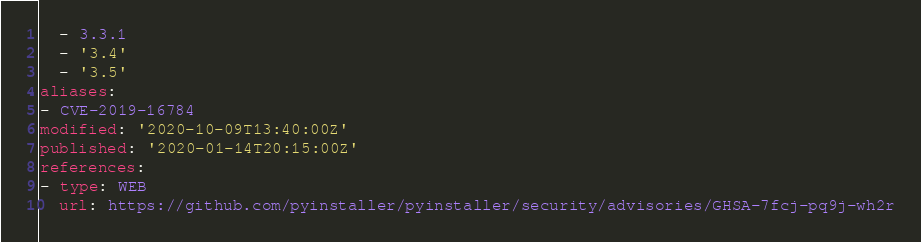Convert code to text. <code><loc_0><loc_0><loc_500><loc_500><_YAML_>  - 3.3.1
  - '3.4'
  - '3.5'
aliases:
- CVE-2019-16784
modified: '2020-10-09T13:40:00Z'
published: '2020-01-14T20:15:00Z'
references:
- type: WEB
  url: https://github.com/pyinstaller/pyinstaller/security/advisories/GHSA-7fcj-pq9j-wh2r
</code> 